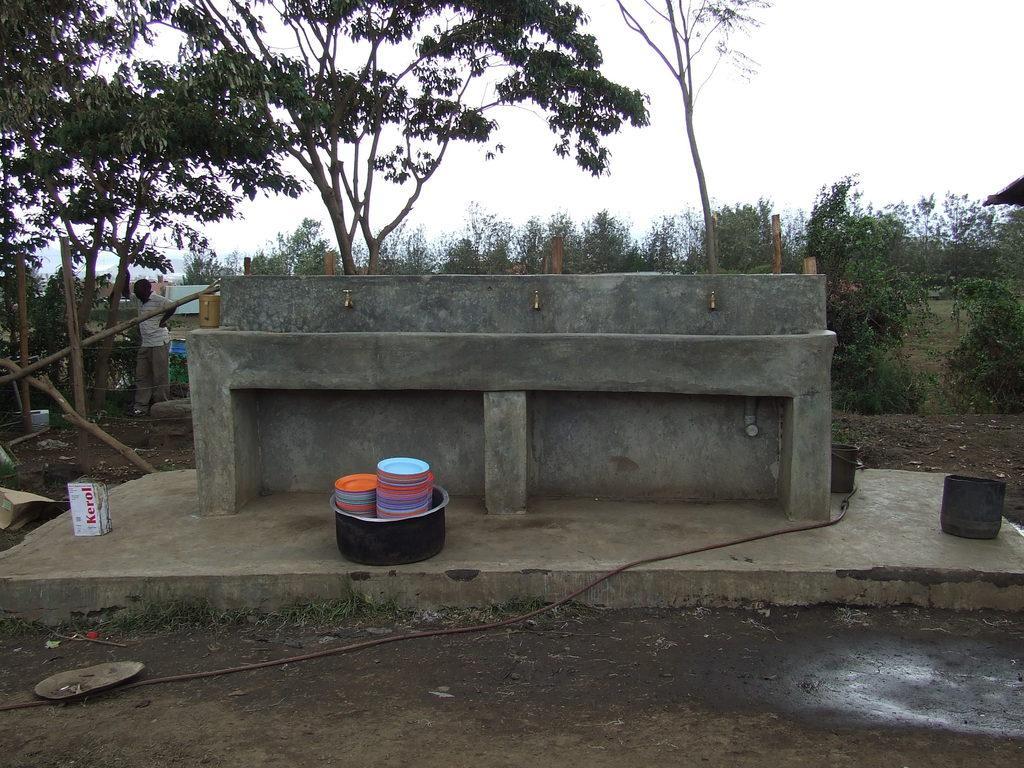Please provide a concise description of this image. In this image we can see a sink, there are some objects on the ground, we can see few trees, poles and a person, in the background we can see the sky. 